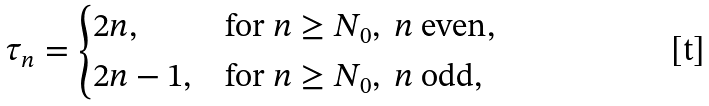<formula> <loc_0><loc_0><loc_500><loc_500>\tau _ { n } = \begin{cases} 2 n , & \text {for } n \geq N _ { 0 } , \ n \text { even} , \\ 2 n - 1 , & \text {for } n \geq N _ { 0 } , \ n \text { odd} , \end{cases}</formula> 